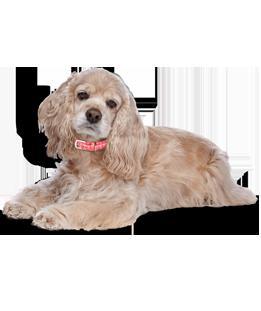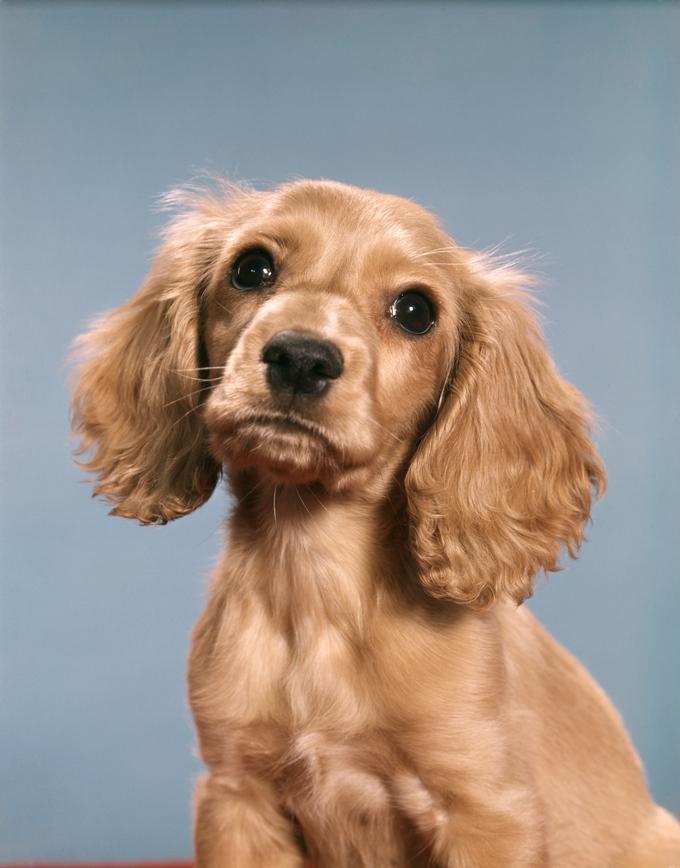The first image is the image on the left, the second image is the image on the right. Evaluate the accuracy of this statement regarding the images: "One of the dogs is wearing a dog collar.". Is it true? Answer yes or no. Yes. 